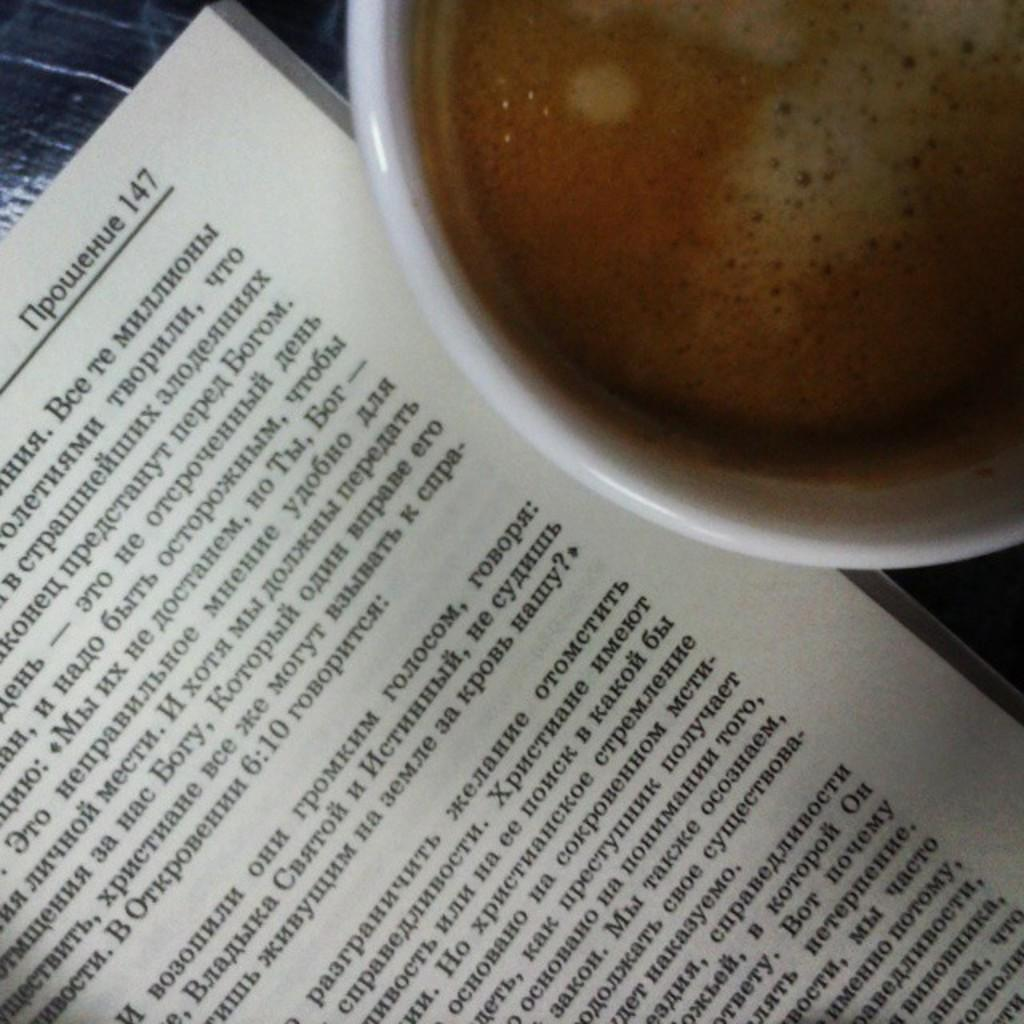What object can be seen in the image related to reading or learning? There is a book in the image. What beverage is present in the image? There is a mug with coffee in the image. Where are the book and mug located in the image? Both objects are on a table. What type of behavior is the book exhibiting in the image? The book is an inanimate object and does not exhibit behavior. Can you see any icicles hanging from the table in the image? There are no icicles present in the image. 